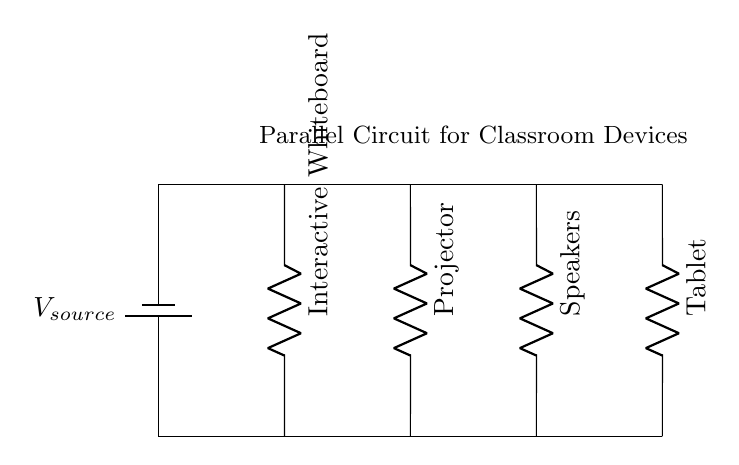What is the source voltage? The battery is labeled as V_source, which represents the source voltage. Since no specific value is given in the diagram, we refer to it as V_source.
Answer: V_source How many devices are connected in parallel? The diagram shows four devices: the interactive whiteboard, projector, speakers, and tablet. Since they are all connected along the same horizontal lines above and below, they are in parallel.
Answer: Four What type of circuit is represented? The connections indicate that all devices receive the same voltage from the source, which is characteristic of a parallel circuit, where each component connects directly to the voltage source.
Answer: Parallel circuit Which device is closest to the source? The interactive whiteboard is placed immediately next to the battery in the diagram, indicating it is the closest device to the voltage source.
Answer: Interactive Whiteboard What happens to the current if one device fails? In a parallel circuit, if one device fails, the other devices will continue to function normally because they are connected independently to the source.
Answer: Others continue to function What is the relationship between current in this circuit? In a parallel circuit, the total current supplied from the source is the sum of the currents through each individual device. Each device can have a different current based on its resistance.
Answer: Sum of individual currents 